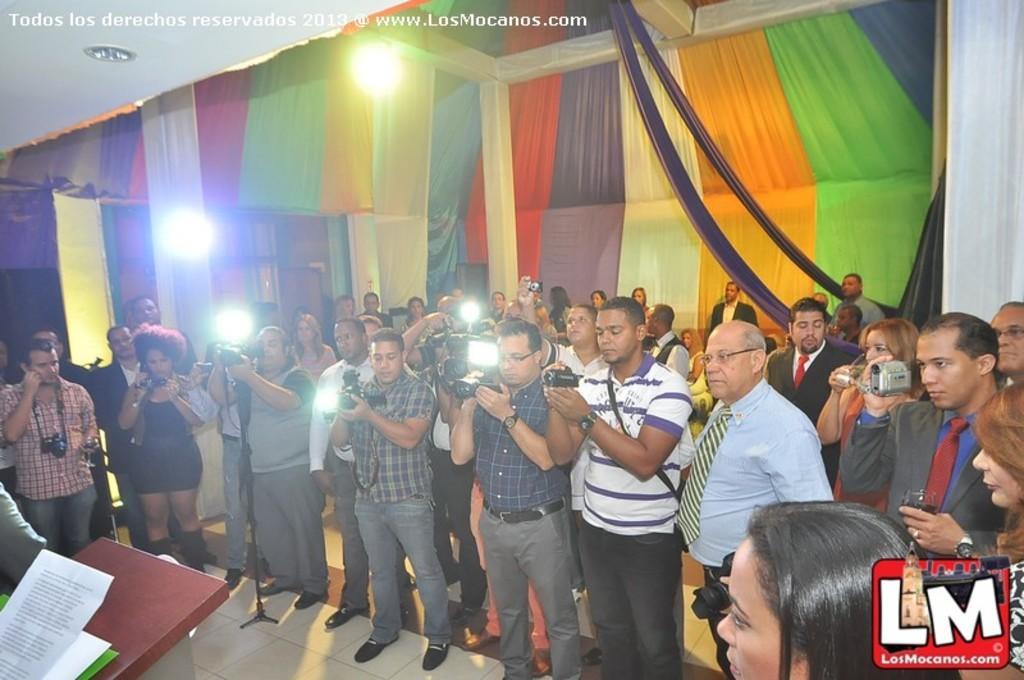Please provide a concise description of this image. In this picture we can see a group of people on the floor and some are holding cameras with their hands and in front of them we can see papers on the podium and in the background we can see the lights, curtains, speakers and some objects. 